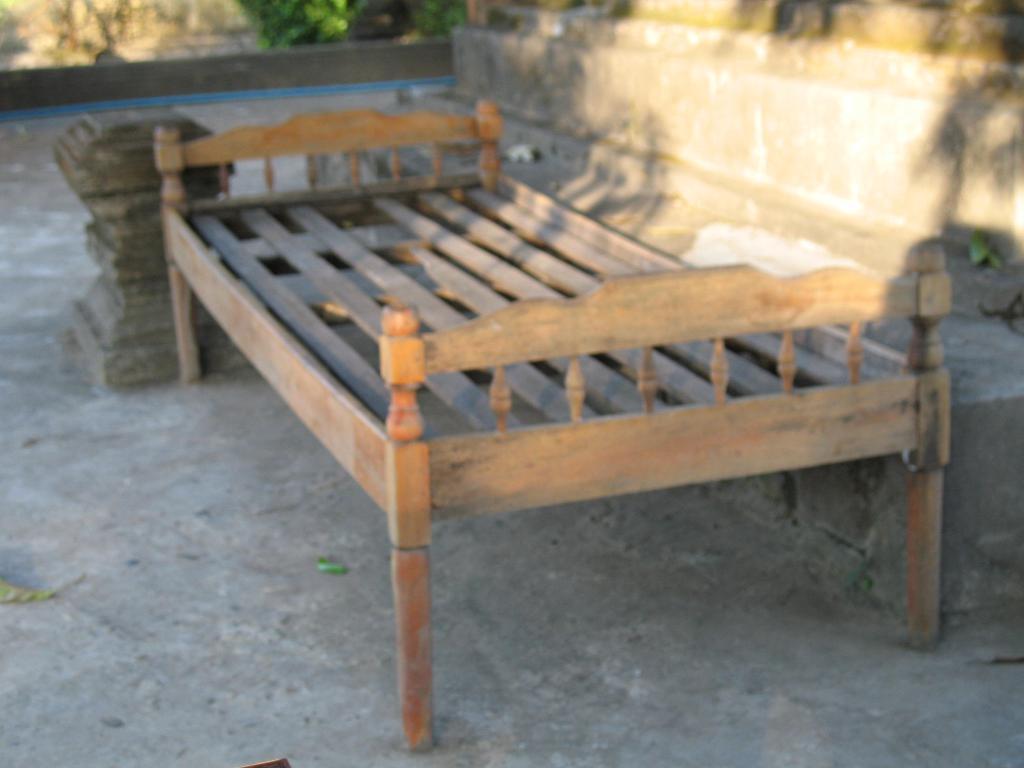Please provide a concise description of this image. In this image there is a bed on the ground, there is a wall truncated towards the top of the image, there is a wall truncated towards the right of the image, there are trees truncated towards the top of the image, there is a wall truncated towards the left of the image, there are objects on the ground, there is an object truncated towards the bottom of the image, there is the ground truncated towards the left of the image, there is an object truncated towards the left of the image , there is the ground truncated towards the bottom of the image. 